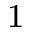<formula> <loc_0><loc_0><loc_500><loc_500>^ { 1 }</formula> 